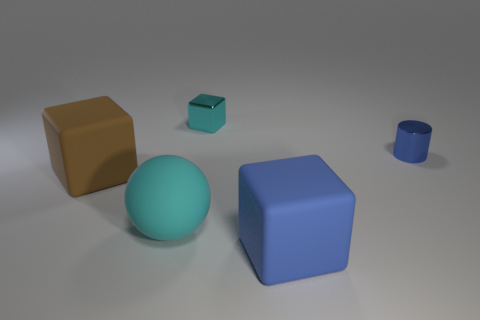Is the color of the rubber sphere the same as the shiny block?
Offer a very short reply. Yes. Is there anything else that has the same color as the shiny cylinder?
Ensure brevity in your answer.  Yes. What is the shape of the metallic object that is the same color as the big matte ball?
Your answer should be very brief. Cube. Are there fewer cyan matte balls to the right of the blue cylinder than large rubber balls?
Your answer should be very brief. Yes. Is there a brown matte object of the same shape as the cyan metal object?
Provide a short and direct response. Yes. The metallic object that is the same size as the shiny cylinder is what shape?
Ensure brevity in your answer.  Cube. How many objects are tiny cyan metallic cylinders or large matte spheres?
Provide a succinct answer. 1. Are any blue cylinders visible?
Give a very brief answer. Yes. Are there fewer small brown metal spheres than big cyan spheres?
Give a very brief answer. Yes. Are there any brown things that have the same size as the matte sphere?
Ensure brevity in your answer.  Yes. 